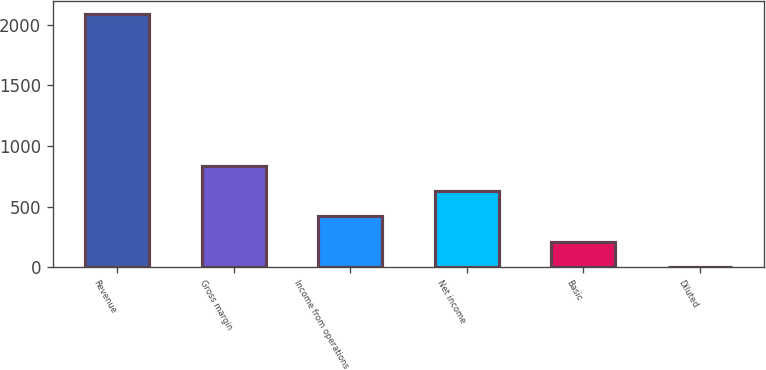<chart> <loc_0><loc_0><loc_500><loc_500><bar_chart><fcel>Revenue<fcel>Gross margin<fcel>Income from operations<fcel>Net income<fcel>Basic<fcel>Diluted<nl><fcel>2088<fcel>835.54<fcel>418.04<fcel>626.79<fcel>209.29<fcel>0.54<nl></chart> 